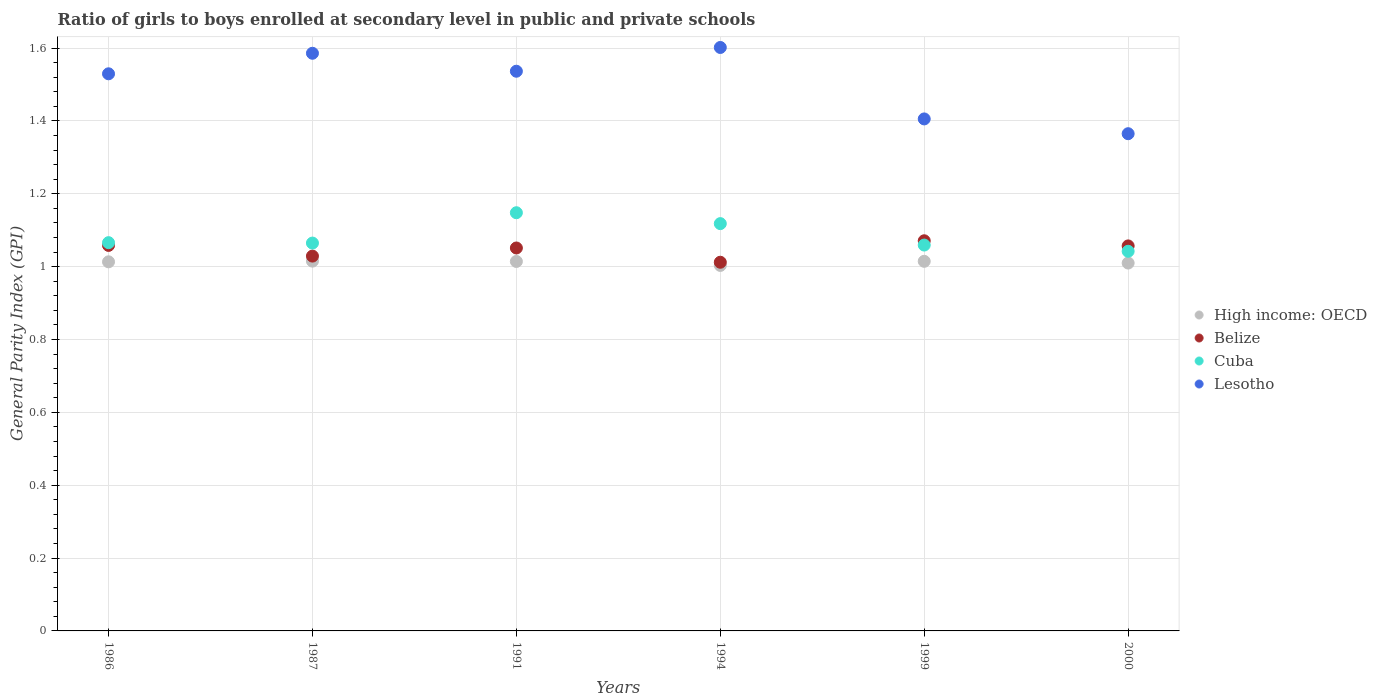How many different coloured dotlines are there?
Give a very brief answer. 4. What is the general parity index in Belize in 1991?
Provide a succinct answer. 1.05. Across all years, what is the maximum general parity index in Lesotho?
Make the answer very short. 1.6. Across all years, what is the minimum general parity index in Cuba?
Your response must be concise. 1.04. What is the total general parity index in Lesotho in the graph?
Provide a short and direct response. 9.02. What is the difference between the general parity index in Lesotho in 1987 and that in 1991?
Offer a terse response. 0.05. What is the difference between the general parity index in High income: OECD in 2000 and the general parity index in Cuba in 1987?
Your answer should be very brief. -0.05. What is the average general parity index in Belize per year?
Make the answer very short. 1.05. In the year 2000, what is the difference between the general parity index in Belize and general parity index in Lesotho?
Your response must be concise. -0.31. What is the ratio of the general parity index in Lesotho in 1986 to that in 1994?
Your response must be concise. 0.95. Is the difference between the general parity index in Belize in 1987 and 1991 greater than the difference between the general parity index in Lesotho in 1987 and 1991?
Your answer should be compact. No. What is the difference between the highest and the second highest general parity index in Belize?
Your answer should be very brief. 0.01. What is the difference between the highest and the lowest general parity index in Cuba?
Offer a terse response. 0.11. Is the sum of the general parity index in Cuba in 1986 and 1987 greater than the maximum general parity index in Lesotho across all years?
Your answer should be compact. Yes. Is it the case that in every year, the sum of the general parity index in High income: OECD and general parity index in Lesotho  is greater than the general parity index in Belize?
Your response must be concise. Yes. Is the general parity index in High income: OECD strictly greater than the general parity index in Cuba over the years?
Give a very brief answer. No. Is the general parity index in Lesotho strictly less than the general parity index in High income: OECD over the years?
Make the answer very short. No. How many years are there in the graph?
Your answer should be very brief. 6. Are the values on the major ticks of Y-axis written in scientific E-notation?
Offer a very short reply. No. Does the graph contain any zero values?
Give a very brief answer. No. Does the graph contain grids?
Give a very brief answer. Yes. Where does the legend appear in the graph?
Provide a succinct answer. Center right. How are the legend labels stacked?
Make the answer very short. Vertical. What is the title of the graph?
Your response must be concise. Ratio of girls to boys enrolled at secondary level in public and private schools. Does "Cameroon" appear as one of the legend labels in the graph?
Your answer should be very brief. No. What is the label or title of the X-axis?
Ensure brevity in your answer.  Years. What is the label or title of the Y-axis?
Your response must be concise. General Parity Index (GPI). What is the General Parity Index (GPI) of High income: OECD in 1986?
Offer a terse response. 1.01. What is the General Parity Index (GPI) of Belize in 1986?
Provide a succinct answer. 1.06. What is the General Parity Index (GPI) of Cuba in 1986?
Provide a succinct answer. 1.07. What is the General Parity Index (GPI) of Lesotho in 1986?
Offer a very short reply. 1.53. What is the General Parity Index (GPI) in High income: OECD in 1987?
Ensure brevity in your answer.  1.02. What is the General Parity Index (GPI) in Belize in 1987?
Your answer should be compact. 1.03. What is the General Parity Index (GPI) in Cuba in 1987?
Make the answer very short. 1.06. What is the General Parity Index (GPI) of Lesotho in 1987?
Your answer should be very brief. 1.59. What is the General Parity Index (GPI) in High income: OECD in 1991?
Your answer should be very brief. 1.01. What is the General Parity Index (GPI) in Belize in 1991?
Give a very brief answer. 1.05. What is the General Parity Index (GPI) of Cuba in 1991?
Give a very brief answer. 1.15. What is the General Parity Index (GPI) in Lesotho in 1991?
Offer a very short reply. 1.54. What is the General Parity Index (GPI) in High income: OECD in 1994?
Your answer should be very brief. 1. What is the General Parity Index (GPI) of Belize in 1994?
Offer a terse response. 1.01. What is the General Parity Index (GPI) of Cuba in 1994?
Your answer should be compact. 1.12. What is the General Parity Index (GPI) in Lesotho in 1994?
Give a very brief answer. 1.6. What is the General Parity Index (GPI) in High income: OECD in 1999?
Offer a very short reply. 1.01. What is the General Parity Index (GPI) in Belize in 1999?
Your response must be concise. 1.07. What is the General Parity Index (GPI) in Cuba in 1999?
Your answer should be compact. 1.06. What is the General Parity Index (GPI) of Lesotho in 1999?
Your response must be concise. 1.41. What is the General Parity Index (GPI) in High income: OECD in 2000?
Give a very brief answer. 1.01. What is the General Parity Index (GPI) in Belize in 2000?
Provide a short and direct response. 1.06. What is the General Parity Index (GPI) of Cuba in 2000?
Provide a short and direct response. 1.04. What is the General Parity Index (GPI) of Lesotho in 2000?
Give a very brief answer. 1.37. Across all years, what is the maximum General Parity Index (GPI) of High income: OECD?
Your answer should be very brief. 1.02. Across all years, what is the maximum General Parity Index (GPI) in Belize?
Offer a terse response. 1.07. Across all years, what is the maximum General Parity Index (GPI) of Cuba?
Your response must be concise. 1.15. Across all years, what is the maximum General Parity Index (GPI) of Lesotho?
Ensure brevity in your answer.  1.6. Across all years, what is the minimum General Parity Index (GPI) in High income: OECD?
Offer a terse response. 1. Across all years, what is the minimum General Parity Index (GPI) in Belize?
Provide a short and direct response. 1.01. Across all years, what is the minimum General Parity Index (GPI) of Cuba?
Provide a succinct answer. 1.04. Across all years, what is the minimum General Parity Index (GPI) of Lesotho?
Your response must be concise. 1.37. What is the total General Parity Index (GPI) in High income: OECD in the graph?
Your answer should be very brief. 6.07. What is the total General Parity Index (GPI) of Belize in the graph?
Keep it short and to the point. 6.28. What is the total General Parity Index (GPI) in Cuba in the graph?
Make the answer very short. 6.5. What is the total General Parity Index (GPI) in Lesotho in the graph?
Make the answer very short. 9.02. What is the difference between the General Parity Index (GPI) in High income: OECD in 1986 and that in 1987?
Make the answer very short. -0. What is the difference between the General Parity Index (GPI) in Belize in 1986 and that in 1987?
Your answer should be very brief. 0.03. What is the difference between the General Parity Index (GPI) of Cuba in 1986 and that in 1987?
Keep it short and to the point. 0. What is the difference between the General Parity Index (GPI) in Lesotho in 1986 and that in 1987?
Your answer should be compact. -0.06. What is the difference between the General Parity Index (GPI) of High income: OECD in 1986 and that in 1991?
Your answer should be very brief. -0. What is the difference between the General Parity Index (GPI) in Belize in 1986 and that in 1991?
Your answer should be very brief. 0.01. What is the difference between the General Parity Index (GPI) of Cuba in 1986 and that in 1991?
Your answer should be compact. -0.08. What is the difference between the General Parity Index (GPI) in Lesotho in 1986 and that in 1991?
Offer a terse response. -0.01. What is the difference between the General Parity Index (GPI) of High income: OECD in 1986 and that in 1994?
Ensure brevity in your answer.  0.01. What is the difference between the General Parity Index (GPI) of Belize in 1986 and that in 1994?
Keep it short and to the point. 0.05. What is the difference between the General Parity Index (GPI) in Cuba in 1986 and that in 1994?
Offer a very short reply. -0.05. What is the difference between the General Parity Index (GPI) of Lesotho in 1986 and that in 1994?
Provide a succinct answer. -0.07. What is the difference between the General Parity Index (GPI) of High income: OECD in 1986 and that in 1999?
Provide a succinct answer. -0. What is the difference between the General Parity Index (GPI) of Belize in 1986 and that in 1999?
Your answer should be compact. -0.01. What is the difference between the General Parity Index (GPI) of Cuba in 1986 and that in 1999?
Provide a short and direct response. 0.01. What is the difference between the General Parity Index (GPI) of Lesotho in 1986 and that in 1999?
Give a very brief answer. 0.12. What is the difference between the General Parity Index (GPI) in High income: OECD in 1986 and that in 2000?
Ensure brevity in your answer.  0. What is the difference between the General Parity Index (GPI) of Belize in 1986 and that in 2000?
Keep it short and to the point. 0. What is the difference between the General Parity Index (GPI) of Cuba in 1986 and that in 2000?
Ensure brevity in your answer.  0.02. What is the difference between the General Parity Index (GPI) of Lesotho in 1986 and that in 2000?
Your response must be concise. 0.16. What is the difference between the General Parity Index (GPI) of High income: OECD in 1987 and that in 1991?
Your response must be concise. 0. What is the difference between the General Parity Index (GPI) of Belize in 1987 and that in 1991?
Make the answer very short. -0.02. What is the difference between the General Parity Index (GPI) of Cuba in 1987 and that in 1991?
Provide a short and direct response. -0.08. What is the difference between the General Parity Index (GPI) in Lesotho in 1987 and that in 1991?
Your response must be concise. 0.05. What is the difference between the General Parity Index (GPI) of High income: OECD in 1987 and that in 1994?
Offer a terse response. 0.01. What is the difference between the General Parity Index (GPI) in Belize in 1987 and that in 1994?
Offer a terse response. 0.02. What is the difference between the General Parity Index (GPI) in Cuba in 1987 and that in 1994?
Your answer should be very brief. -0.05. What is the difference between the General Parity Index (GPI) of Lesotho in 1987 and that in 1994?
Keep it short and to the point. -0.02. What is the difference between the General Parity Index (GPI) in Belize in 1987 and that in 1999?
Ensure brevity in your answer.  -0.04. What is the difference between the General Parity Index (GPI) of Cuba in 1987 and that in 1999?
Give a very brief answer. 0.01. What is the difference between the General Parity Index (GPI) in Lesotho in 1987 and that in 1999?
Offer a very short reply. 0.18. What is the difference between the General Parity Index (GPI) in High income: OECD in 1987 and that in 2000?
Your answer should be compact. 0.01. What is the difference between the General Parity Index (GPI) of Belize in 1987 and that in 2000?
Give a very brief answer. -0.03. What is the difference between the General Parity Index (GPI) in Cuba in 1987 and that in 2000?
Keep it short and to the point. 0.02. What is the difference between the General Parity Index (GPI) in Lesotho in 1987 and that in 2000?
Offer a very short reply. 0.22. What is the difference between the General Parity Index (GPI) in High income: OECD in 1991 and that in 1994?
Provide a short and direct response. 0.01. What is the difference between the General Parity Index (GPI) in Belize in 1991 and that in 1994?
Provide a succinct answer. 0.04. What is the difference between the General Parity Index (GPI) of Cuba in 1991 and that in 1994?
Provide a succinct answer. 0.03. What is the difference between the General Parity Index (GPI) in Lesotho in 1991 and that in 1994?
Make the answer very short. -0.07. What is the difference between the General Parity Index (GPI) in High income: OECD in 1991 and that in 1999?
Ensure brevity in your answer.  -0. What is the difference between the General Parity Index (GPI) in Belize in 1991 and that in 1999?
Offer a very short reply. -0.02. What is the difference between the General Parity Index (GPI) in Cuba in 1991 and that in 1999?
Ensure brevity in your answer.  0.09. What is the difference between the General Parity Index (GPI) of Lesotho in 1991 and that in 1999?
Keep it short and to the point. 0.13. What is the difference between the General Parity Index (GPI) in High income: OECD in 1991 and that in 2000?
Provide a succinct answer. 0. What is the difference between the General Parity Index (GPI) of Belize in 1991 and that in 2000?
Ensure brevity in your answer.  -0.01. What is the difference between the General Parity Index (GPI) of Cuba in 1991 and that in 2000?
Give a very brief answer. 0.11. What is the difference between the General Parity Index (GPI) in Lesotho in 1991 and that in 2000?
Provide a short and direct response. 0.17. What is the difference between the General Parity Index (GPI) of High income: OECD in 1994 and that in 1999?
Offer a terse response. -0.01. What is the difference between the General Parity Index (GPI) of Belize in 1994 and that in 1999?
Give a very brief answer. -0.06. What is the difference between the General Parity Index (GPI) in Cuba in 1994 and that in 1999?
Make the answer very short. 0.06. What is the difference between the General Parity Index (GPI) of Lesotho in 1994 and that in 1999?
Provide a short and direct response. 0.2. What is the difference between the General Parity Index (GPI) in High income: OECD in 1994 and that in 2000?
Keep it short and to the point. -0.01. What is the difference between the General Parity Index (GPI) of Belize in 1994 and that in 2000?
Provide a short and direct response. -0.04. What is the difference between the General Parity Index (GPI) of Cuba in 1994 and that in 2000?
Your answer should be compact. 0.08. What is the difference between the General Parity Index (GPI) of Lesotho in 1994 and that in 2000?
Offer a very short reply. 0.24. What is the difference between the General Parity Index (GPI) in High income: OECD in 1999 and that in 2000?
Offer a terse response. 0. What is the difference between the General Parity Index (GPI) in Belize in 1999 and that in 2000?
Your answer should be compact. 0.01. What is the difference between the General Parity Index (GPI) of Cuba in 1999 and that in 2000?
Keep it short and to the point. 0.02. What is the difference between the General Parity Index (GPI) of Lesotho in 1999 and that in 2000?
Provide a succinct answer. 0.04. What is the difference between the General Parity Index (GPI) of High income: OECD in 1986 and the General Parity Index (GPI) of Belize in 1987?
Offer a very short reply. -0.02. What is the difference between the General Parity Index (GPI) in High income: OECD in 1986 and the General Parity Index (GPI) in Cuba in 1987?
Keep it short and to the point. -0.05. What is the difference between the General Parity Index (GPI) of High income: OECD in 1986 and the General Parity Index (GPI) of Lesotho in 1987?
Make the answer very short. -0.57. What is the difference between the General Parity Index (GPI) in Belize in 1986 and the General Parity Index (GPI) in Cuba in 1987?
Keep it short and to the point. -0.01. What is the difference between the General Parity Index (GPI) of Belize in 1986 and the General Parity Index (GPI) of Lesotho in 1987?
Make the answer very short. -0.53. What is the difference between the General Parity Index (GPI) of Cuba in 1986 and the General Parity Index (GPI) of Lesotho in 1987?
Your answer should be very brief. -0.52. What is the difference between the General Parity Index (GPI) in High income: OECD in 1986 and the General Parity Index (GPI) in Belize in 1991?
Provide a short and direct response. -0.04. What is the difference between the General Parity Index (GPI) in High income: OECD in 1986 and the General Parity Index (GPI) in Cuba in 1991?
Provide a succinct answer. -0.13. What is the difference between the General Parity Index (GPI) in High income: OECD in 1986 and the General Parity Index (GPI) in Lesotho in 1991?
Provide a short and direct response. -0.52. What is the difference between the General Parity Index (GPI) in Belize in 1986 and the General Parity Index (GPI) in Cuba in 1991?
Give a very brief answer. -0.09. What is the difference between the General Parity Index (GPI) in Belize in 1986 and the General Parity Index (GPI) in Lesotho in 1991?
Provide a succinct answer. -0.48. What is the difference between the General Parity Index (GPI) in Cuba in 1986 and the General Parity Index (GPI) in Lesotho in 1991?
Offer a terse response. -0.47. What is the difference between the General Parity Index (GPI) in High income: OECD in 1986 and the General Parity Index (GPI) in Belize in 1994?
Offer a very short reply. 0. What is the difference between the General Parity Index (GPI) of High income: OECD in 1986 and the General Parity Index (GPI) of Cuba in 1994?
Provide a short and direct response. -0.1. What is the difference between the General Parity Index (GPI) in High income: OECD in 1986 and the General Parity Index (GPI) in Lesotho in 1994?
Your answer should be compact. -0.59. What is the difference between the General Parity Index (GPI) of Belize in 1986 and the General Parity Index (GPI) of Cuba in 1994?
Ensure brevity in your answer.  -0.06. What is the difference between the General Parity Index (GPI) of Belize in 1986 and the General Parity Index (GPI) of Lesotho in 1994?
Provide a succinct answer. -0.54. What is the difference between the General Parity Index (GPI) in Cuba in 1986 and the General Parity Index (GPI) in Lesotho in 1994?
Provide a short and direct response. -0.54. What is the difference between the General Parity Index (GPI) of High income: OECD in 1986 and the General Parity Index (GPI) of Belize in 1999?
Keep it short and to the point. -0.06. What is the difference between the General Parity Index (GPI) in High income: OECD in 1986 and the General Parity Index (GPI) in Cuba in 1999?
Offer a terse response. -0.05. What is the difference between the General Parity Index (GPI) of High income: OECD in 1986 and the General Parity Index (GPI) of Lesotho in 1999?
Your response must be concise. -0.39. What is the difference between the General Parity Index (GPI) in Belize in 1986 and the General Parity Index (GPI) in Cuba in 1999?
Your response must be concise. -0. What is the difference between the General Parity Index (GPI) of Belize in 1986 and the General Parity Index (GPI) of Lesotho in 1999?
Your answer should be very brief. -0.35. What is the difference between the General Parity Index (GPI) in Cuba in 1986 and the General Parity Index (GPI) in Lesotho in 1999?
Give a very brief answer. -0.34. What is the difference between the General Parity Index (GPI) in High income: OECD in 1986 and the General Parity Index (GPI) in Belize in 2000?
Offer a terse response. -0.04. What is the difference between the General Parity Index (GPI) of High income: OECD in 1986 and the General Parity Index (GPI) of Cuba in 2000?
Your answer should be compact. -0.03. What is the difference between the General Parity Index (GPI) of High income: OECD in 1986 and the General Parity Index (GPI) of Lesotho in 2000?
Offer a very short reply. -0.35. What is the difference between the General Parity Index (GPI) in Belize in 1986 and the General Parity Index (GPI) in Cuba in 2000?
Your answer should be very brief. 0.02. What is the difference between the General Parity Index (GPI) of Belize in 1986 and the General Parity Index (GPI) of Lesotho in 2000?
Provide a short and direct response. -0.31. What is the difference between the General Parity Index (GPI) in Cuba in 1986 and the General Parity Index (GPI) in Lesotho in 2000?
Ensure brevity in your answer.  -0.3. What is the difference between the General Parity Index (GPI) of High income: OECD in 1987 and the General Parity Index (GPI) of Belize in 1991?
Give a very brief answer. -0.04. What is the difference between the General Parity Index (GPI) in High income: OECD in 1987 and the General Parity Index (GPI) in Cuba in 1991?
Ensure brevity in your answer.  -0.13. What is the difference between the General Parity Index (GPI) in High income: OECD in 1987 and the General Parity Index (GPI) in Lesotho in 1991?
Your answer should be very brief. -0.52. What is the difference between the General Parity Index (GPI) in Belize in 1987 and the General Parity Index (GPI) in Cuba in 1991?
Offer a terse response. -0.12. What is the difference between the General Parity Index (GPI) of Belize in 1987 and the General Parity Index (GPI) of Lesotho in 1991?
Ensure brevity in your answer.  -0.51. What is the difference between the General Parity Index (GPI) of Cuba in 1987 and the General Parity Index (GPI) of Lesotho in 1991?
Provide a short and direct response. -0.47. What is the difference between the General Parity Index (GPI) in High income: OECD in 1987 and the General Parity Index (GPI) in Belize in 1994?
Your answer should be very brief. 0. What is the difference between the General Parity Index (GPI) in High income: OECD in 1987 and the General Parity Index (GPI) in Cuba in 1994?
Keep it short and to the point. -0.1. What is the difference between the General Parity Index (GPI) of High income: OECD in 1987 and the General Parity Index (GPI) of Lesotho in 1994?
Make the answer very short. -0.59. What is the difference between the General Parity Index (GPI) in Belize in 1987 and the General Parity Index (GPI) in Cuba in 1994?
Give a very brief answer. -0.09. What is the difference between the General Parity Index (GPI) in Belize in 1987 and the General Parity Index (GPI) in Lesotho in 1994?
Your answer should be compact. -0.57. What is the difference between the General Parity Index (GPI) in Cuba in 1987 and the General Parity Index (GPI) in Lesotho in 1994?
Provide a succinct answer. -0.54. What is the difference between the General Parity Index (GPI) in High income: OECD in 1987 and the General Parity Index (GPI) in Belize in 1999?
Offer a terse response. -0.06. What is the difference between the General Parity Index (GPI) of High income: OECD in 1987 and the General Parity Index (GPI) of Cuba in 1999?
Your answer should be very brief. -0.04. What is the difference between the General Parity Index (GPI) in High income: OECD in 1987 and the General Parity Index (GPI) in Lesotho in 1999?
Offer a terse response. -0.39. What is the difference between the General Parity Index (GPI) in Belize in 1987 and the General Parity Index (GPI) in Cuba in 1999?
Offer a very short reply. -0.03. What is the difference between the General Parity Index (GPI) of Belize in 1987 and the General Parity Index (GPI) of Lesotho in 1999?
Your response must be concise. -0.38. What is the difference between the General Parity Index (GPI) in Cuba in 1987 and the General Parity Index (GPI) in Lesotho in 1999?
Offer a very short reply. -0.34. What is the difference between the General Parity Index (GPI) of High income: OECD in 1987 and the General Parity Index (GPI) of Belize in 2000?
Make the answer very short. -0.04. What is the difference between the General Parity Index (GPI) in High income: OECD in 1987 and the General Parity Index (GPI) in Cuba in 2000?
Your answer should be compact. -0.03. What is the difference between the General Parity Index (GPI) in High income: OECD in 1987 and the General Parity Index (GPI) in Lesotho in 2000?
Give a very brief answer. -0.35. What is the difference between the General Parity Index (GPI) of Belize in 1987 and the General Parity Index (GPI) of Cuba in 2000?
Give a very brief answer. -0.01. What is the difference between the General Parity Index (GPI) of Belize in 1987 and the General Parity Index (GPI) of Lesotho in 2000?
Offer a very short reply. -0.34. What is the difference between the General Parity Index (GPI) of Cuba in 1987 and the General Parity Index (GPI) of Lesotho in 2000?
Offer a terse response. -0.3. What is the difference between the General Parity Index (GPI) in High income: OECD in 1991 and the General Parity Index (GPI) in Belize in 1994?
Your answer should be very brief. 0. What is the difference between the General Parity Index (GPI) of High income: OECD in 1991 and the General Parity Index (GPI) of Cuba in 1994?
Provide a short and direct response. -0.1. What is the difference between the General Parity Index (GPI) of High income: OECD in 1991 and the General Parity Index (GPI) of Lesotho in 1994?
Give a very brief answer. -0.59. What is the difference between the General Parity Index (GPI) of Belize in 1991 and the General Parity Index (GPI) of Cuba in 1994?
Offer a terse response. -0.07. What is the difference between the General Parity Index (GPI) of Belize in 1991 and the General Parity Index (GPI) of Lesotho in 1994?
Make the answer very short. -0.55. What is the difference between the General Parity Index (GPI) in Cuba in 1991 and the General Parity Index (GPI) in Lesotho in 1994?
Provide a short and direct response. -0.45. What is the difference between the General Parity Index (GPI) of High income: OECD in 1991 and the General Parity Index (GPI) of Belize in 1999?
Your answer should be compact. -0.06. What is the difference between the General Parity Index (GPI) of High income: OECD in 1991 and the General Parity Index (GPI) of Cuba in 1999?
Your answer should be very brief. -0.04. What is the difference between the General Parity Index (GPI) in High income: OECD in 1991 and the General Parity Index (GPI) in Lesotho in 1999?
Keep it short and to the point. -0.39. What is the difference between the General Parity Index (GPI) of Belize in 1991 and the General Parity Index (GPI) of Cuba in 1999?
Offer a terse response. -0.01. What is the difference between the General Parity Index (GPI) of Belize in 1991 and the General Parity Index (GPI) of Lesotho in 1999?
Offer a terse response. -0.35. What is the difference between the General Parity Index (GPI) of Cuba in 1991 and the General Parity Index (GPI) of Lesotho in 1999?
Ensure brevity in your answer.  -0.26. What is the difference between the General Parity Index (GPI) in High income: OECD in 1991 and the General Parity Index (GPI) in Belize in 2000?
Provide a succinct answer. -0.04. What is the difference between the General Parity Index (GPI) in High income: OECD in 1991 and the General Parity Index (GPI) in Cuba in 2000?
Offer a very short reply. -0.03. What is the difference between the General Parity Index (GPI) in High income: OECD in 1991 and the General Parity Index (GPI) in Lesotho in 2000?
Provide a short and direct response. -0.35. What is the difference between the General Parity Index (GPI) of Belize in 1991 and the General Parity Index (GPI) of Cuba in 2000?
Your answer should be compact. 0.01. What is the difference between the General Parity Index (GPI) in Belize in 1991 and the General Parity Index (GPI) in Lesotho in 2000?
Your answer should be compact. -0.31. What is the difference between the General Parity Index (GPI) of Cuba in 1991 and the General Parity Index (GPI) of Lesotho in 2000?
Your answer should be compact. -0.22. What is the difference between the General Parity Index (GPI) of High income: OECD in 1994 and the General Parity Index (GPI) of Belize in 1999?
Your response must be concise. -0.07. What is the difference between the General Parity Index (GPI) of High income: OECD in 1994 and the General Parity Index (GPI) of Cuba in 1999?
Ensure brevity in your answer.  -0.06. What is the difference between the General Parity Index (GPI) in High income: OECD in 1994 and the General Parity Index (GPI) in Lesotho in 1999?
Provide a succinct answer. -0.4. What is the difference between the General Parity Index (GPI) of Belize in 1994 and the General Parity Index (GPI) of Cuba in 1999?
Your response must be concise. -0.05. What is the difference between the General Parity Index (GPI) of Belize in 1994 and the General Parity Index (GPI) of Lesotho in 1999?
Offer a terse response. -0.39. What is the difference between the General Parity Index (GPI) of Cuba in 1994 and the General Parity Index (GPI) of Lesotho in 1999?
Make the answer very short. -0.29. What is the difference between the General Parity Index (GPI) in High income: OECD in 1994 and the General Parity Index (GPI) in Belize in 2000?
Provide a succinct answer. -0.05. What is the difference between the General Parity Index (GPI) in High income: OECD in 1994 and the General Parity Index (GPI) in Cuba in 2000?
Provide a succinct answer. -0.04. What is the difference between the General Parity Index (GPI) of High income: OECD in 1994 and the General Parity Index (GPI) of Lesotho in 2000?
Provide a short and direct response. -0.36. What is the difference between the General Parity Index (GPI) of Belize in 1994 and the General Parity Index (GPI) of Cuba in 2000?
Provide a succinct answer. -0.03. What is the difference between the General Parity Index (GPI) in Belize in 1994 and the General Parity Index (GPI) in Lesotho in 2000?
Offer a terse response. -0.35. What is the difference between the General Parity Index (GPI) of Cuba in 1994 and the General Parity Index (GPI) of Lesotho in 2000?
Offer a very short reply. -0.25. What is the difference between the General Parity Index (GPI) in High income: OECD in 1999 and the General Parity Index (GPI) in Belize in 2000?
Provide a short and direct response. -0.04. What is the difference between the General Parity Index (GPI) of High income: OECD in 1999 and the General Parity Index (GPI) of Cuba in 2000?
Ensure brevity in your answer.  -0.03. What is the difference between the General Parity Index (GPI) in High income: OECD in 1999 and the General Parity Index (GPI) in Lesotho in 2000?
Your answer should be compact. -0.35. What is the difference between the General Parity Index (GPI) in Belize in 1999 and the General Parity Index (GPI) in Cuba in 2000?
Provide a succinct answer. 0.03. What is the difference between the General Parity Index (GPI) in Belize in 1999 and the General Parity Index (GPI) in Lesotho in 2000?
Offer a very short reply. -0.29. What is the difference between the General Parity Index (GPI) of Cuba in 1999 and the General Parity Index (GPI) of Lesotho in 2000?
Give a very brief answer. -0.31. What is the average General Parity Index (GPI) of High income: OECD per year?
Keep it short and to the point. 1.01. What is the average General Parity Index (GPI) of Belize per year?
Your answer should be very brief. 1.05. What is the average General Parity Index (GPI) in Cuba per year?
Make the answer very short. 1.08. What is the average General Parity Index (GPI) in Lesotho per year?
Your response must be concise. 1.5. In the year 1986, what is the difference between the General Parity Index (GPI) in High income: OECD and General Parity Index (GPI) in Belize?
Offer a very short reply. -0.04. In the year 1986, what is the difference between the General Parity Index (GPI) in High income: OECD and General Parity Index (GPI) in Cuba?
Your response must be concise. -0.05. In the year 1986, what is the difference between the General Parity Index (GPI) in High income: OECD and General Parity Index (GPI) in Lesotho?
Your answer should be very brief. -0.52. In the year 1986, what is the difference between the General Parity Index (GPI) in Belize and General Parity Index (GPI) in Cuba?
Your response must be concise. -0.01. In the year 1986, what is the difference between the General Parity Index (GPI) in Belize and General Parity Index (GPI) in Lesotho?
Offer a very short reply. -0.47. In the year 1986, what is the difference between the General Parity Index (GPI) of Cuba and General Parity Index (GPI) of Lesotho?
Offer a very short reply. -0.46. In the year 1987, what is the difference between the General Parity Index (GPI) of High income: OECD and General Parity Index (GPI) of Belize?
Give a very brief answer. -0.01. In the year 1987, what is the difference between the General Parity Index (GPI) in High income: OECD and General Parity Index (GPI) in Cuba?
Your answer should be compact. -0.05. In the year 1987, what is the difference between the General Parity Index (GPI) of High income: OECD and General Parity Index (GPI) of Lesotho?
Provide a succinct answer. -0.57. In the year 1987, what is the difference between the General Parity Index (GPI) of Belize and General Parity Index (GPI) of Cuba?
Provide a succinct answer. -0.04. In the year 1987, what is the difference between the General Parity Index (GPI) in Belize and General Parity Index (GPI) in Lesotho?
Give a very brief answer. -0.56. In the year 1987, what is the difference between the General Parity Index (GPI) in Cuba and General Parity Index (GPI) in Lesotho?
Keep it short and to the point. -0.52. In the year 1991, what is the difference between the General Parity Index (GPI) in High income: OECD and General Parity Index (GPI) in Belize?
Give a very brief answer. -0.04. In the year 1991, what is the difference between the General Parity Index (GPI) in High income: OECD and General Parity Index (GPI) in Cuba?
Your answer should be compact. -0.13. In the year 1991, what is the difference between the General Parity Index (GPI) of High income: OECD and General Parity Index (GPI) of Lesotho?
Offer a terse response. -0.52. In the year 1991, what is the difference between the General Parity Index (GPI) of Belize and General Parity Index (GPI) of Cuba?
Provide a succinct answer. -0.1. In the year 1991, what is the difference between the General Parity Index (GPI) in Belize and General Parity Index (GPI) in Lesotho?
Your answer should be compact. -0.49. In the year 1991, what is the difference between the General Parity Index (GPI) of Cuba and General Parity Index (GPI) of Lesotho?
Offer a terse response. -0.39. In the year 1994, what is the difference between the General Parity Index (GPI) of High income: OECD and General Parity Index (GPI) of Belize?
Give a very brief answer. -0.01. In the year 1994, what is the difference between the General Parity Index (GPI) in High income: OECD and General Parity Index (GPI) in Cuba?
Your answer should be compact. -0.11. In the year 1994, what is the difference between the General Parity Index (GPI) in High income: OECD and General Parity Index (GPI) in Lesotho?
Your answer should be compact. -0.6. In the year 1994, what is the difference between the General Parity Index (GPI) of Belize and General Parity Index (GPI) of Cuba?
Offer a terse response. -0.11. In the year 1994, what is the difference between the General Parity Index (GPI) in Belize and General Parity Index (GPI) in Lesotho?
Provide a succinct answer. -0.59. In the year 1994, what is the difference between the General Parity Index (GPI) in Cuba and General Parity Index (GPI) in Lesotho?
Your answer should be very brief. -0.48. In the year 1999, what is the difference between the General Parity Index (GPI) in High income: OECD and General Parity Index (GPI) in Belize?
Ensure brevity in your answer.  -0.06. In the year 1999, what is the difference between the General Parity Index (GPI) of High income: OECD and General Parity Index (GPI) of Cuba?
Keep it short and to the point. -0.04. In the year 1999, what is the difference between the General Parity Index (GPI) in High income: OECD and General Parity Index (GPI) in Lesotho?
Your answer should be compact. -0.39. In the year 1999, what is the difference between the General Parity Index (GPI) in Belize and General Parity Index (GPI) in Cuba?
Offer a very short reply. 0.01. In the year 1999, what is the difference between the General Parity Index (GPI) in Belize and General Parity Index (GPI) in Lesotho?
Your response must be concise. -0.33. In the year 1999, what is the difference between the General Parity Index (GPI) of Cuba and General Parity Index (GPI) of Lesotho?
Offer a very short reply. -0.35. In the year 2000, what is the difference between the General Parity Index (GPI) in High income: OECD and General Parity Index (GPI) in Belize?
Offer a very short reply. -0.05. In the year 2000, what is the difference between the General Parity Index (GPI) of High income: OECD and General Parity Index (GPI) of Cuba?
Your answer should be very brief. -0.03. In the year 2000, what is the difference between the General Parity Index (GPI) in High income: OECD and General Parity Index (GPI) in Lesotho?
Ensure brevity in your answer.  -0.36. In the year 2000, what is the difference between the General Parity Index (GPI) of Belize and General Parity Index (GPI) of Cuba?
Offer a terse response. 0.01. In the year 2000, what is the difference between the General Parity Index (GPI) in Belize and General Parity Index (GPI) in Lesotho?
Offer a terse response. -0.31. In the year 2000, what is the difference between the General Parity Index (GPI) in Cuba and General Parity Index (GPI) in Lesotho?
Make the answer very short. -0.32. What is the ratio of the General Parity Index (GPI) in High income: OECD in 1986 to that in 1987?
Give a very brief answer. 1. What is the ratio of the General Parity Index (GPI) in Belize in 1986 to that in 1987?
Make the answer very short. 1.03. What is the ratio of the General Parity Index (GPI) in Lesotho in 1986 to that in 1987?
Offer a very short reply. 0.96. What is the ratio of the General Parity Index (GPI) in High income: OECD in 1986 to that in 1991?
Offer a very short reply. 1. What is the ratio of the General Parity Index (GPI) of Belize in 1986 to that in 1991?
Your response must be concise. 1.01. What is the ratio of the General Parity Index (GPI) of Cuba in 1986 to that in 1991?
Make the answer very short. 0.93. What is the ratio of the General Parity Index (GPI) in High income: OECD in 1986 to that in 1994?
Offer a very short reply. 1.01. What is the ratio of the General Parity Index (GPI) in Belize in 1986 to that in 1994?
Ensure brevity in your answer.  1.05. What is the ratio of the General Parity Index (GPI) of Cuba in 1986 to that in 1994?
Your answer should be compact. 0.95. What is the ratio of the General Parity Index (GPI) in Lesotho in 1986 to that in 1994?
Provide a short and direct response. 0.95. What is the ratio of the General Parity Index (GPI) in High income: OECD in 1986 to that in 1999?
Your response must be concise. 1. What is the ratio of the General Parity Index (GPI) in Belize in 1986 to that in 1999?
Provide a short and direct response. 0.99. What is the ratio of the General Parity Index (GPI) in Cuba in 1986 to that in 1999?
Offer a very short reply. 1.01. What is the ratio of the General Parity Index (GPI) of Lesotho in 1986 to that in 1999?
Provide a short and direct response. 1.09. What is the ratio of the General Parity Index (GPI) in Belize in 1986 to that in 2000?
Your response must be concise. 1. What is the ratio of the General Parity Index (GPI) of Cuba in 1986 to that in 2000?
Ensure brevity in your answer.  1.02. What is the ratio of the General Parity Index (GPI) in Lesotho in 1986 to that in 2000?
Your answer should be very brief. 1.12. What is the ratio of the General Parity Index (GPI) in Belize in 1987 to that in 1991?
Provide a succinct answer. 0.98. What is the ratio of the General Parity Index (GPI) in Cuba in 1987 to that in 1991?
Make the answer very short. 0.93. What is the ratio of the General Parity Index (GPI) in Lesotho in 1987 to that in 1991?
Provide a succinct answer. 1.03. What is the ratio of the General Parity Index (GPI) of High income: OECD in 1987 to that in 1994?
Offer a terse response. 1.01. What is the ratio of the General Parity Index (GPI) of Belize in 1987 to that in 1994?
Make the answer very short. 1.02. What is the ratio of the General Parity Index (GPI) in Cuba in 1987 to that in 1994?
Ensure brevity in your answer.  0.95. What is the ratio of the General Parity Index (GPI) in Belize in 1987 to that in 1999?
Ensure brevity in your answer.  0.96. What is the ratio of the General Parity Index (GPI) of Lesotho in 1987 to that in 1999?
Your answer should be very brief. 1.13. What is the ratio of the General Parity Index (GPI) of High income: OECD in 1987 to that in 2000?
Your response must be concise. 1.01. What is the ratio of the General Parity Index (GPI) of Belize in 1987 to that in 2000?
Offer a very short reply. 0.97. What is the ratio of the General Parity Index (GPI) of Cuba in 1987 to that in 2000?
Your answer should be very brief. 1.02. What is the ratio of the General Parity Index (GPI) of Lesotho in 1987 to that in 2000?
Provide a succinct answer. 1.16. What is the ratio of the General Parity Index (GPI) in High income: OECD in 1991 to that in 1994?
Give a very brief answer. 1.01. What is the ratio of the General Parity Index (GPI) of Belize in 1991 to that in 1994?
Offer a terse response. 1.04. What is the ratio of the General Parity Index (GPI) in Cuba in 1991 to that in 1994?
Give a very brief answer. 1.03. What is the ratio of the General Parity Index (GPI) of Lesotho in 1991 to that in 1994?
Keep it short and to the point. 0.96. What is the ratio of the General Parity Index (GPI) in High income: OECD in 1991 to that in 1999?
Provide a short and direct response. 1. What is the ratio of the General Parity Index (GPI) of Belize in 1991 to that in 1999?
Keep it short and to the point. 0.98. What is the ratio of the General Parity Index (GPI) of Cuba in 1991 to that in 1999?
Your response must be concise. 1.08. What is the ratio of the General Parity Index (GPI) in Lesotho in 1991 to that in 1999?
Make the answer very short. 1.09. What is the ratio of the General Parity Index (GPI) in Cuba in 1991 to that in 2000?
Make the answer very short. 1.1. What is the ratio of the General Parity Index (GPI) in Lesotho in 1991 to that in 2000?
Ensure brevity in your answer.  1.13. What is the ratio of the General Parity Index (GPI) of High income: OECD in 1994 to that in 1999?
Make the answer very short. 0.99. What is the ratio of the General Parity Index (GPI) in Belize in 1994 to that in 1999?
Give a very brief answer. 0.94. What is the ratio of the General Parity Index (GPI) of Cuba in 1994 to that in 1999?
Your response must be concise. 1.06. What is the ratio of the General Parity Index (GPI) in Lesotho in 1994 to that in 1999?
Provide a succinct answer. 1.14. What is the ratio of the General Parity Index (GPI) in High income: OECD in 1994 to that in 2000?
Offer a very short reply. 0.99. What is the ratio of the General Parity Index (GPI) of Belize in 1994 to that in 2000?
Your answer should be very brief. 0.96. What is the ratio of the General Parity Index (GPI) of Cuba in 1994 to that in 2000?
Provide a succinct answer. 1.07. What is the ratio of the General Parity Index (GPI) of Lesotho in 1994 to that in 2000?
Provide a succinct answer. 1.17. What is the ratio of the General Parity Index (GPI) of Belize in 1999 to that in 2000?
Offer a terse response. 1.01. What is the ratio of the General Parity Index (GPI) in Cuba in 1999 to that in 2000?
Offer a very short reply. 1.02. What is the ratio of the General Parity Index (GPI) of Lesotho in 1999 to that in 2000?
Provide a succinct answer. 1.03. What is the difference between the highest and the second highest General Parity Index (GPI) in Belize?
Provide a short and direct response. 0.01. What is the difference between the highest and the second highest General Parity Index (GPI) in Cuba?
Give a very brief answer. 0.03. What is the difference between the highest and the second highest General Parity Index (GPI) in Lesotho?
Your answer should be compact. 0.02. What is the difference between the highest and the lowest General Parity Index (GPI) of High income: OECD?
Keep it short and to the point. 0.01. What is the difference between the highest and the lowest General Parity Index (GPI) in Belize?
Give a very brief answer. 0.06. What is the difference between the highest and the lowest General Parity Index (GPI) in Cuba?
Offer a terse response. 0.11. What is the difference between the highest and the lowest General Parity Index (GPI) in Lesotho?
Ensure brevity in your answer.  0.24. 